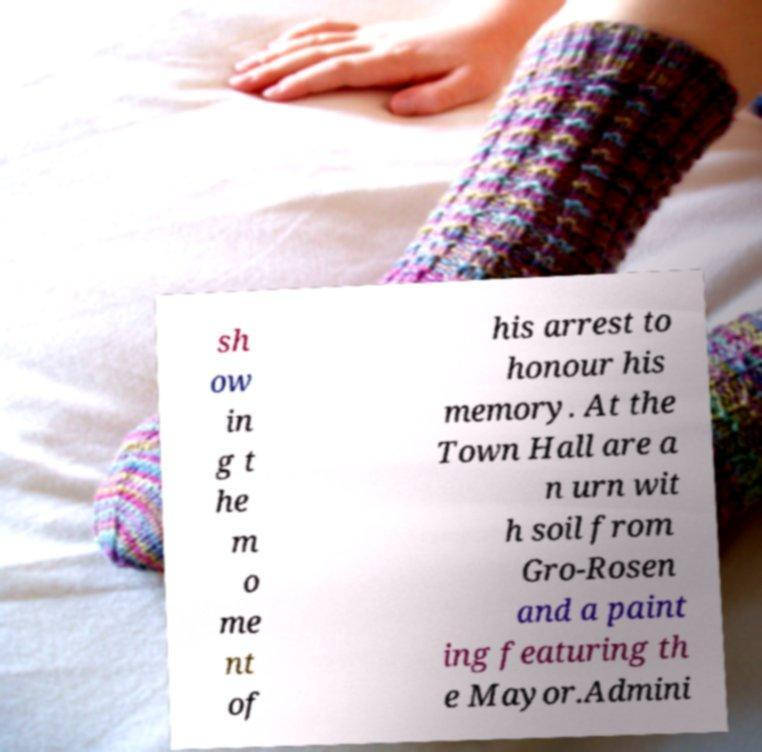There's text embedded in this image that I need extracted. Can you transcribe it verbatim? sh ow in g t he m o me nt of his arrest to honour his memory. At the Town Hall are a n urn wit h soil from Gro-Rosen and a paint ing featuring th e Mayor.Admini 